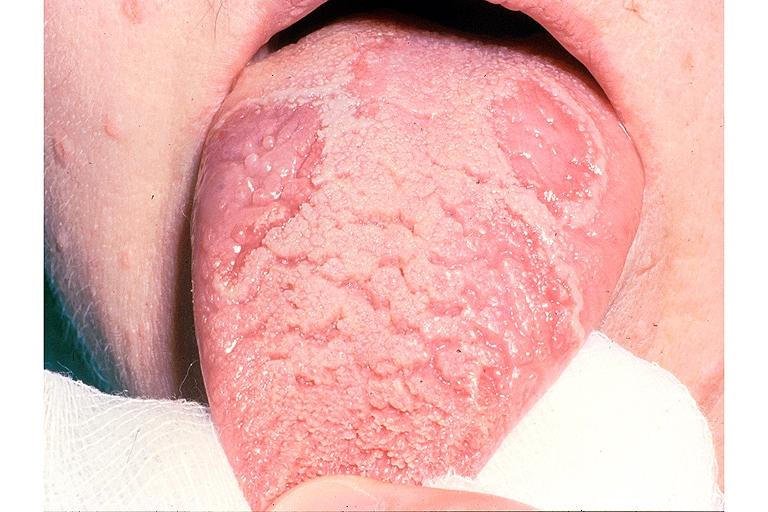what does this image show?
Answer the question using a single word or phrase. Benign migratory glossitis and fissured tongue 